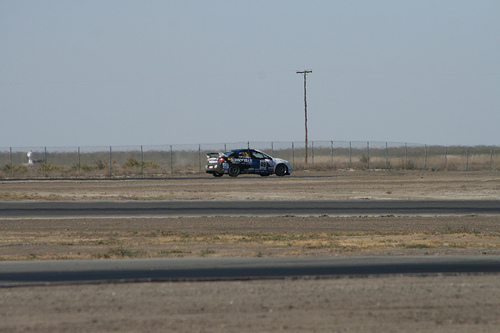<image>
Is there a car above the road? No. The car is not positioned above the road. The vertical arrangement shows a different relationship. 